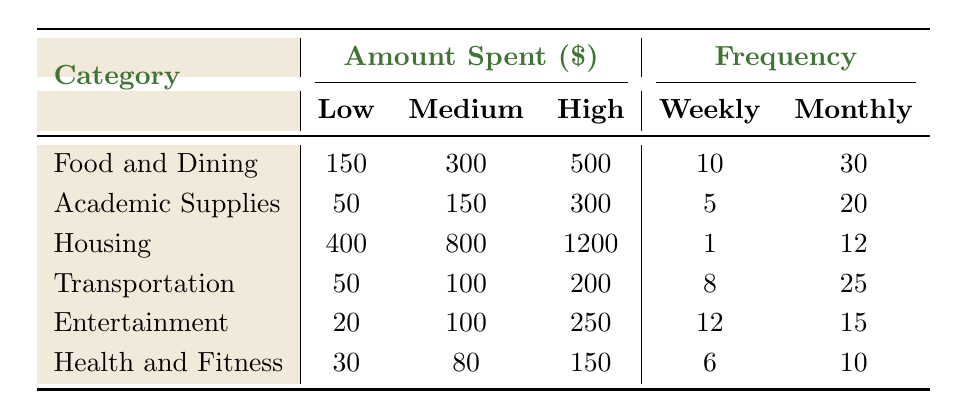What is the highest amount spent in the Food and Dining category? The Food and Dining category lists amounts spent as Low: 150, Medium: 300, and High: 500. The highest amount is clearly listed as 500.
Answer: 500 How many students spend weekly on Entertainment? The table shows that 12 students spend weekly on Entertainment. This value is retrieved directly from the table in the Frequency section.
Answer: 12 What is the total amount spent on Housing per month? The Housing category reports monthly spending as Low: 400, Medium: 800, and High: 1200. Adding these amounts gives 400 + 800 + 1200 = 2400.
Answer: 2400 Are more students spending on Food and Dining weekly than on Academic Supplies? The Frequency section shows 10 students spend weekly on Food and Dining, while 5 students spend weekly on Academic Supplies. Since 10 is greater than 5, the statement is true.
Answer: Yes How much more do students spend on Transportation compared to Health and Fitness weekly? In the Frequency row, Transportation indicates 8 weekly spenders, while Health and Fitness indicates 6. 
The amounts for Transportation are Low: 50, Medium: 100, High: 200; totaling 50 + 100 + 200 = 350. For Health and Fitness, the total is Low: 30, Medium: 80, High: 150; totaling 30 + 80 + 150 = 260. 
The difference is 350 - 260 = 90.
Answer: 90 